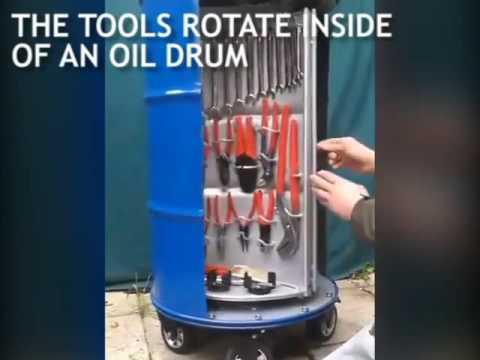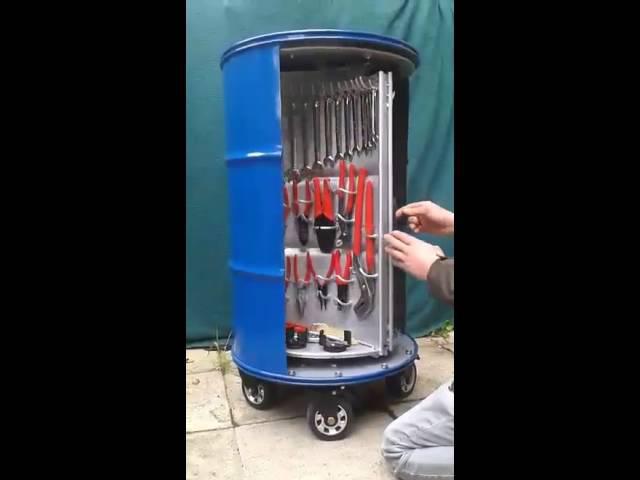The first image is the image on the left, the second image is the image on the right. Analyze the images presented: Is the assertion "The right image shows an empty barrel with a hinged opening, and the left image shows a tool-filled blue barrel with an open front." valid? Answer yes or no. No. 